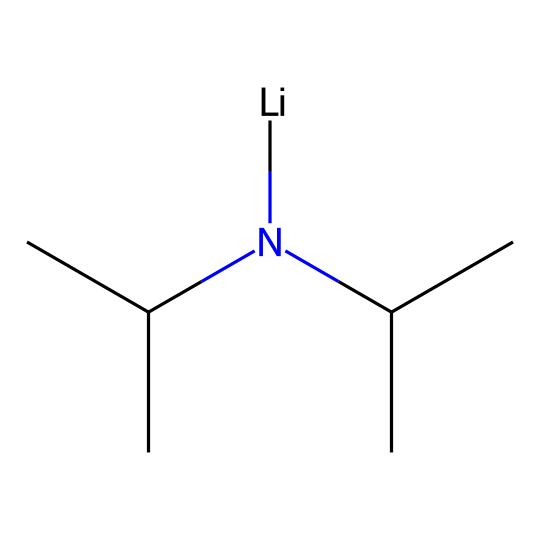What is the central atom in lithium diisopropylamide? The structure shows a lithium atom [Li] which is the central atom bonded to the nitrogen atom. The lithium in this molecule plays a key role in its basicity.
Answer: lithium How many isopropyl groups are present in this molecule? The SMILES representation indicates the nitrogen is bonded to two isopropyl groups (C(C)C), signifying that there are two instances of this group present, highlighting its diisopropyl nature.
Answer: two What type of bonding is primarily responsible for the reactivity of lithium diisopropylamide? The significant basicity of LDA comes from the nitrogen atom, as it is a strong Lewis base capable of donating electron pairs, thus participating in ionic or coordinate bonds with substrates.
Answer: nitrogen What role does lithium play in lithium diisopropylamide? Lithium acts as a counterion that stabilizes the negative charge formed on the nitrogen during reactions, enhancing the molecule's overall basicity and reactivity in organic synthesis.
Answer: counterion What is the total number of carbon atoms in lithium diisopropylamide? Within the structure, each of the two isopropyl groups contributes three carbon atoms, and since there are two isopropyl groups, the total number of carbon atoms is six, plus the carbon from nitrogen's coordinates.
Answer: six What property makes lithium diisopropylamide classified as a superbase? The remarkable basicity is attributed to the nitrogen atom's ability to deprotonate weak acids effectively, leading to its classification as a superbase in synthetic chemistry.
Answer: basicity 